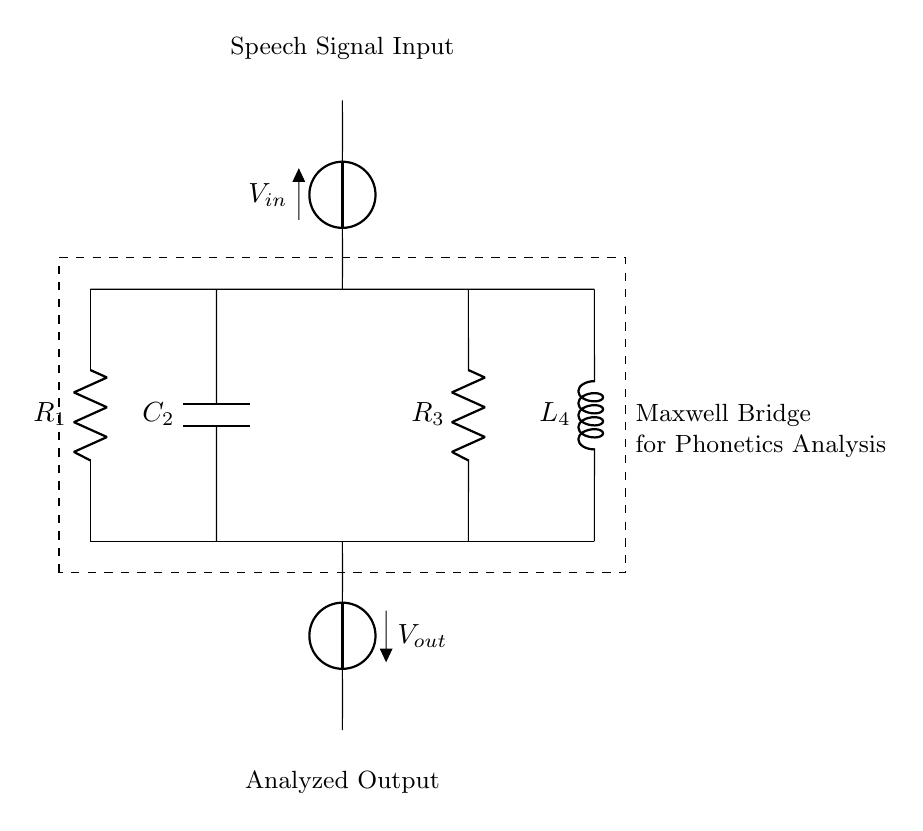What is the main purpose of this circuit? The main purpose is to analyze speech waveforms in phonetics studies using a Maxwell bridge configuration, which allows for precise measurements of reactive components.
Answer: analyze speech waveforms What are the components present in this circuit? The circuit contains a resistor R1, a capacitor C2, another resistor R3, and an inductor L4, which are essential for its operation in measuring impedance.
Answer: R1, C2, R3, L4 What type of circuit is this? This circuit is a Maxwell bridge, which specifically involves resistors and reactive components for impedance measurement in AC circuits.
Answer: Maxwell bridge What is the significance of the input voltage labeled V_in? V_in represents the speech signal input voltage which is crucial for analyzing the variations in speech waveforms as they are introduced into the circuit.
Answer: speech signal input How many branches does this circuit have? The circuit has four branches: one for each component (R1, C2, R3, L4) across the two voltage source connections.
Answer: four branches Why is C2 important in this circuit? C2 is important as it reacts to the speech signal changes, allowing the circuit to analyze frequency and phase components of the input waveform, key to phonetic studies.
Answer: analyzes frequency and phase What does the output voltage labeled V_out indicate? V_out indicates the analyzed output of the circuit, which gives insight into the speech waveform characteristics processed through the Maxwell bridge.
Answer: analyzed output 